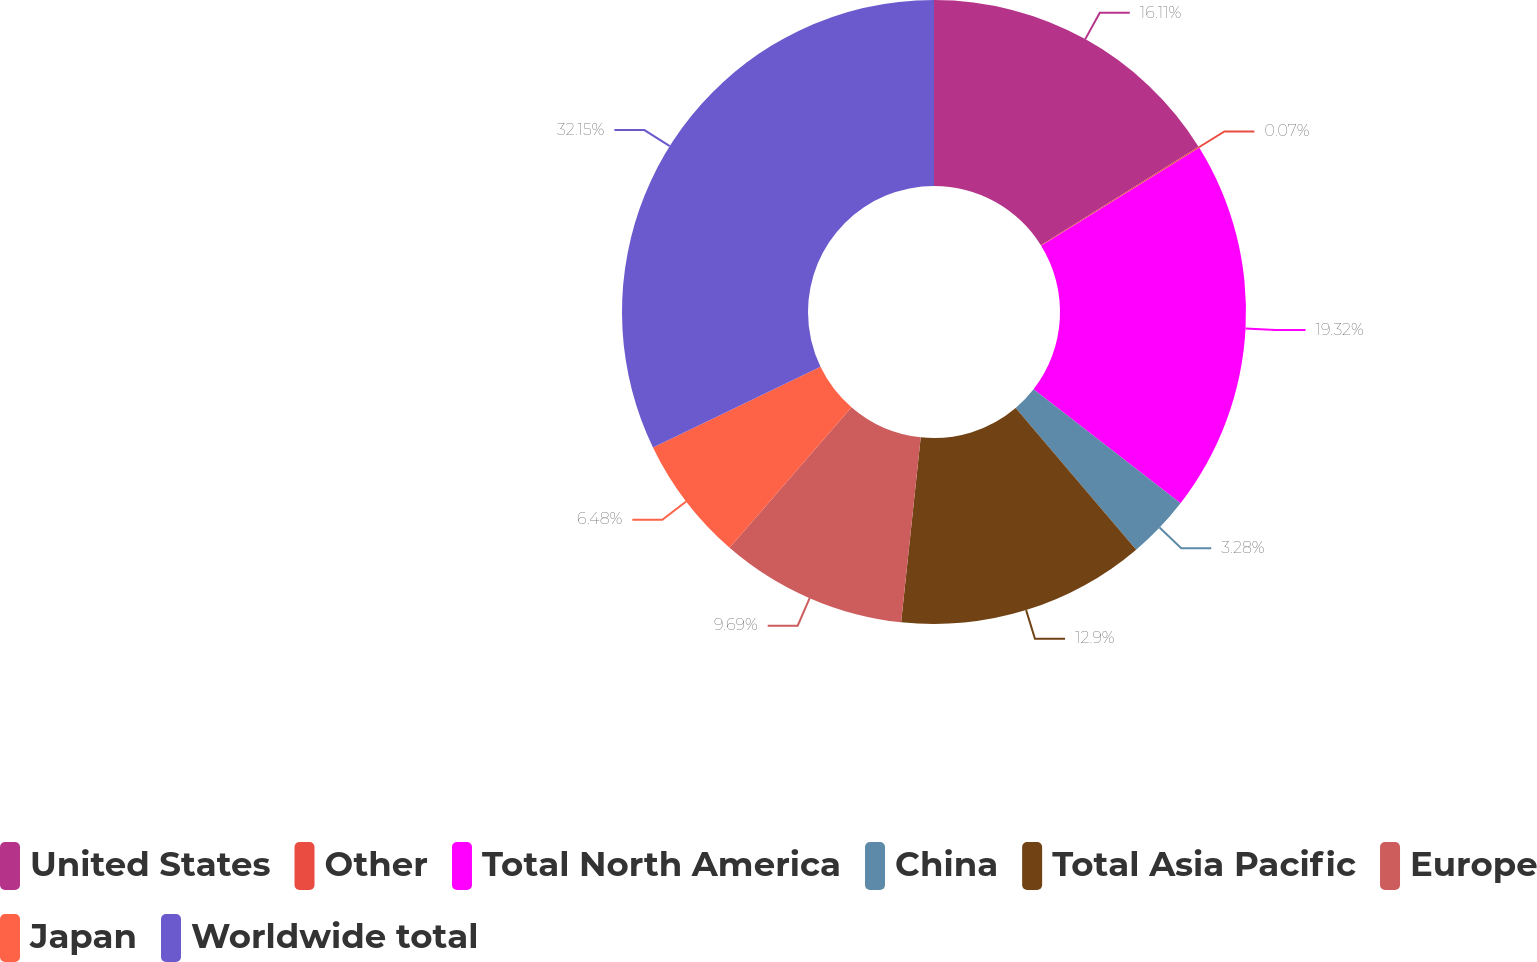Convert chart. <chart><loc_0><loc_0><loc_500><loc_500><pie_chart><fcel>United States<fcel>Other<fcel>Total North America<fcel>China<fcel>Total Asia Pacific<fcel>Europe<fcel>Japan<fcel>Worldwide total<nl><fcel>16.11%<fcel>0.07%<fcel>19.32%<fcel>3.28%<fcel>12.9%<fcel>9.69%<fcel>6.48%<fcel>32.15%<nl></chart> 